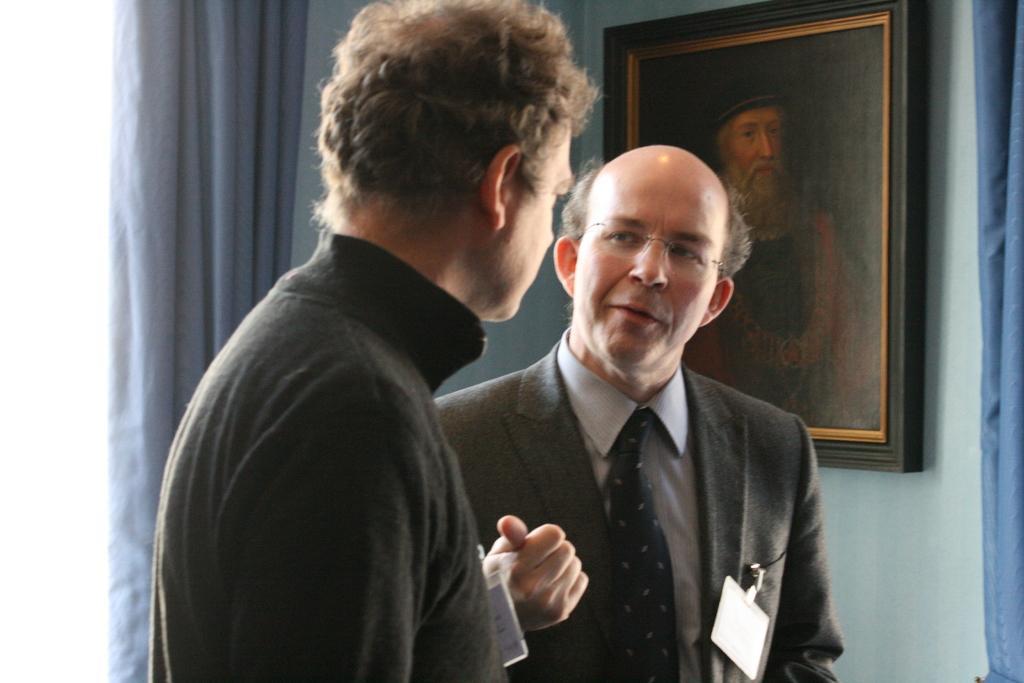Could you give a brief overview of what you see in this image? In this image I can see two persons both are wearing a black color clothes and on the right side I can see the wall and a photo frame attached to the wall and I can see a blue color curtain on the left side. 